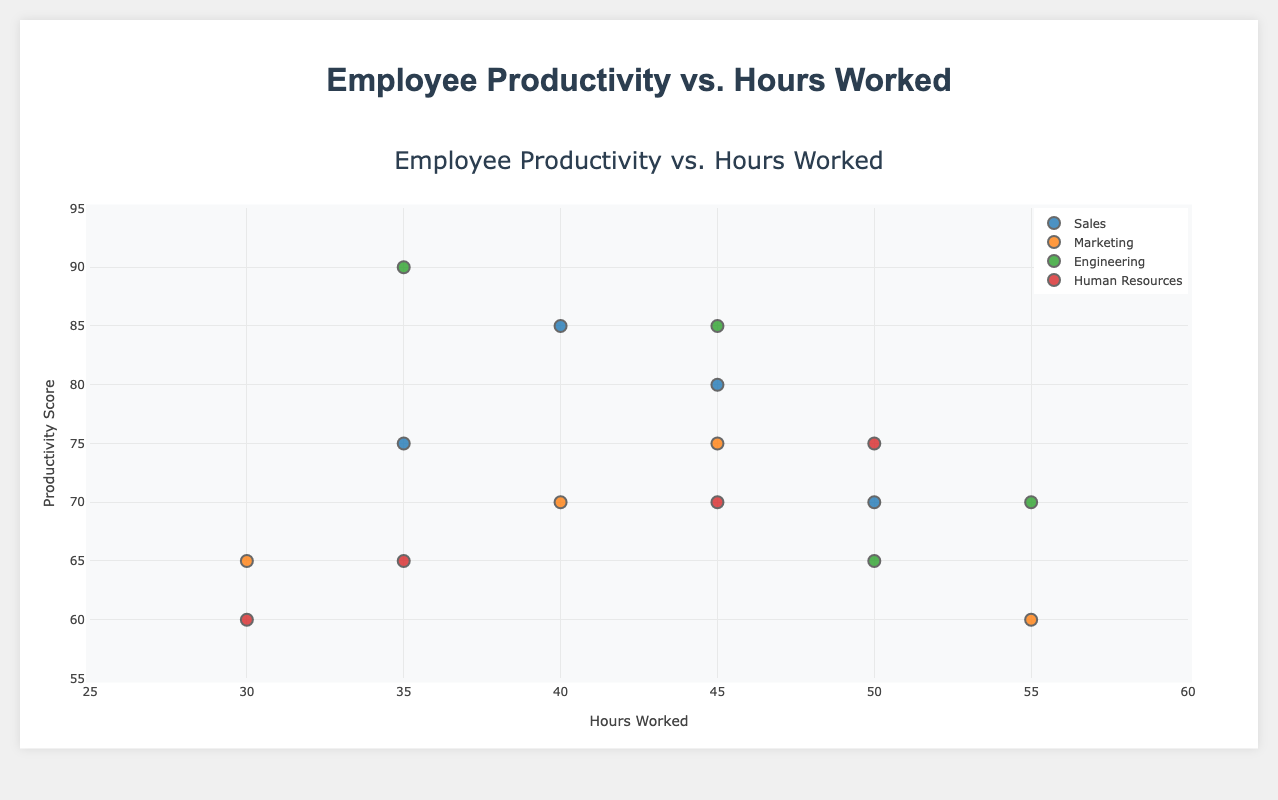What is the title of the figure? The title of the figure is displayed at the top center of the chart. It reads "Employee Productivity vs. Hours Worked".
Answer: Employee Productivity vs. Hours Worked How many departments are represented in the figure? There are four distinct departments represented in the figure, visually differentiated by their unique markers and labeled on the legend to the right of the chart.
Answer: 4 Which department has an employee with the highest productivity score? By observing the y-axis of the scatter plot, the highest productivity score is 90, which is attributed to "Chris Wilson" from the Engineering department.
Answer: Engineering What are the hours worked and productivity score for the employee "John Doe"? Locate "John Doe" in the Sales department from the hover info. His details indicate 35 hours worked and a productivity score of 75.
Answer: 35 hours, 75 Who works the most hours in the Marketing department, and what is their productivity score? In the Marketing department, "David Rodriguez" works the most hours, indicated by his position on the x-axis at 55 hours. His productivity score is 60, located on the y-axis.
Answer: David Rodriguez, 60 Which department shows the widest range in hours worked among its employees? The range can be determined by subtracting the minimum hours worked from the maximum for each department. Human Resources ranges from 30 to 50 hours (20 hours), which is less than Engineering's range from 35 to 55 hours (20 hours identical), but Marketing shows a wider range of 25 hours (30 to 55), hence the widest range.
Answer: Marketing Among all departments, which one has the employee with the lowest productivity score and how many hours do they work? The lowest productivity score across all departments is 60, associated with "David Rodriguez" in Marketing, who works 55 hours as shown on the x-axis.
Answer: Marketing, 55 hours What is the average productivity score of employees in the Engineering department? To calculate the average, sum the productivity scores for Engineering (90, 85, 65, 70) and divide by the number of employees (4). The calculation is (90 + 85 + 65 + 70)/4 = 77.5.
Answer: 77.5 